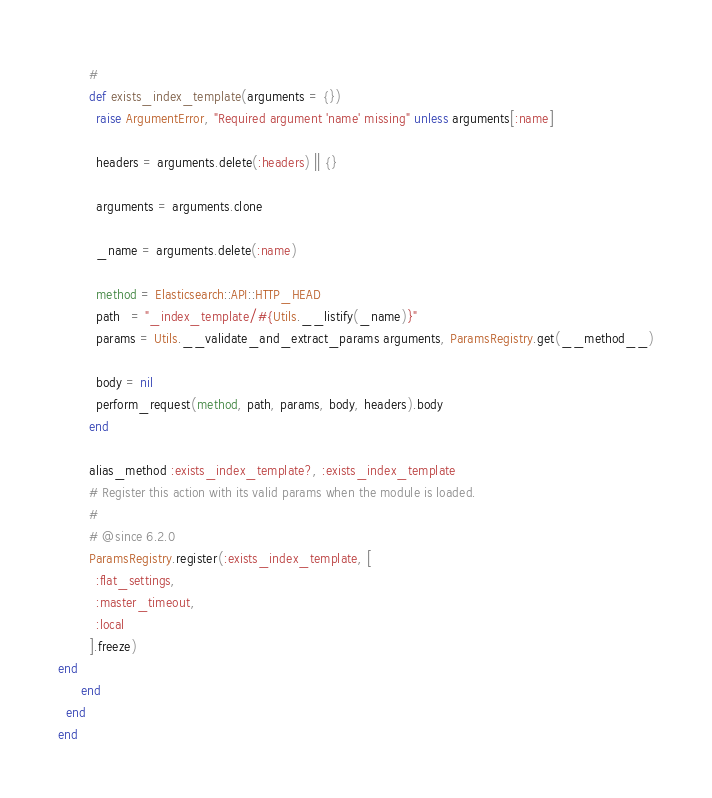Convert code to text. <code><loc_0><loc_0><loc_500><loc_500><_Ruby_>        #
        def exists_index_template(arguments = {})
          raise ArgumentError, "Required argument 'name' missing" unless arguments[:name]

          headers = arguments.delete(:headers) || {}

          arguments = arguments.clone

          _name = arguments.delete(:name)

          method = Elasticsearch::API::HTTP_HEAD
          path   = "_index_template/#{Utils.__listify(_name)}"
          params = Utils.__validate_and_extract_params arguments, ParamsRegistry.get(__method__)

          body = nil
          perform_request(method, path, params, body, headers).body
        end

        alias_method :exists_index_template?, :exists_index_template
        # Register this action with its valid params when the module is loaded.
        #
        # @since 6.2.0
        ParamsRegistry.register(:exists_index_template, [
          :flat_settings,
          :master_timeout,
          :local
        ].freeze)
end
      end
  end
end
</code> 